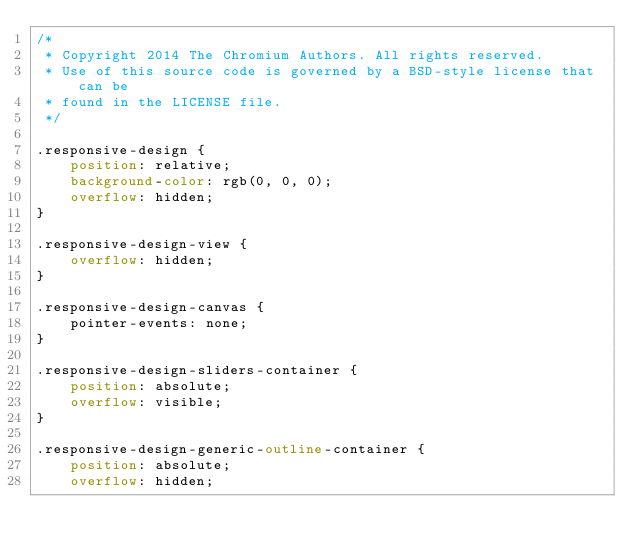<code> <loc_0><loc_0><loc_500><loc_500><_CSS_>/*
 * Copyright 2014 The Chromium Authors. All rights reserved.
 * Use of this source code is governed by a BSD-style license that can be
 * found in the LICENSE file.
 */

.responsive-design {
    position: relative;
    background-color: rgb(0, 0, 0);
    overflow: hidden;
}

.responsive-design-view {
    overflow: hidden;
}

.responsive-design-canvas {
    pointer-events: none;
}

.responsive-design-sliders-container {
    position: absolute;
    overflow: visible;
}

.responsive-design-generic-outline-container {
    position: absolute;
    overflow: hidden;</code> 